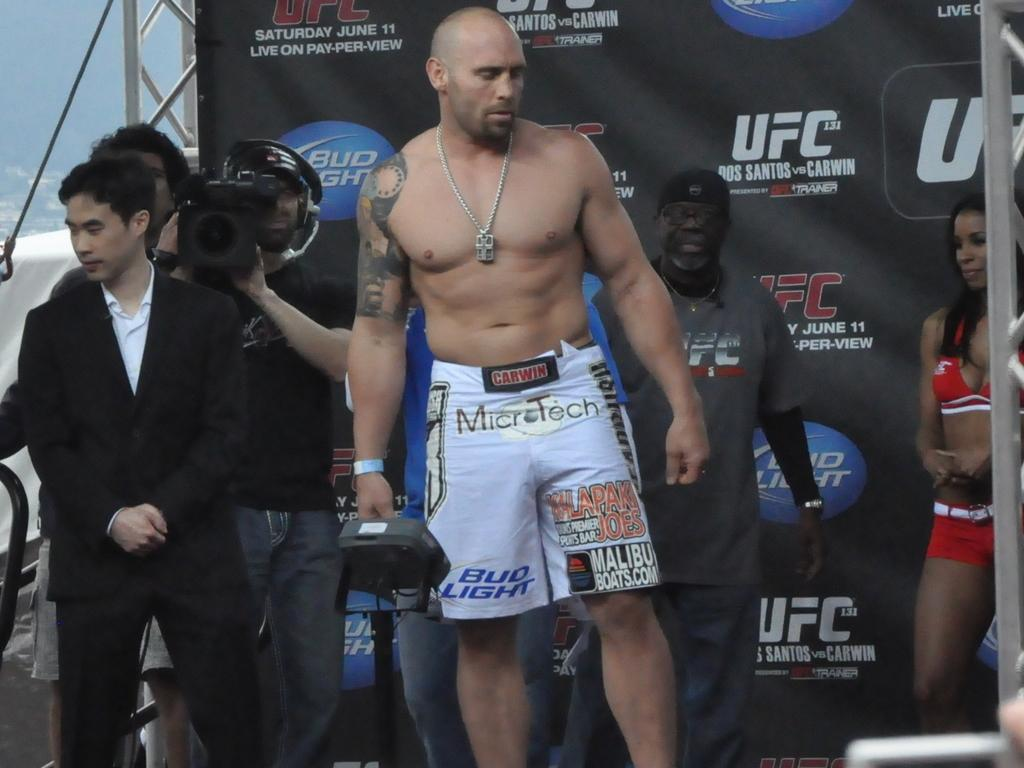Provide a one-sentence caption for the provided image. A man wearing Microtech wrestling shorts stands in front of a UFC sign. 